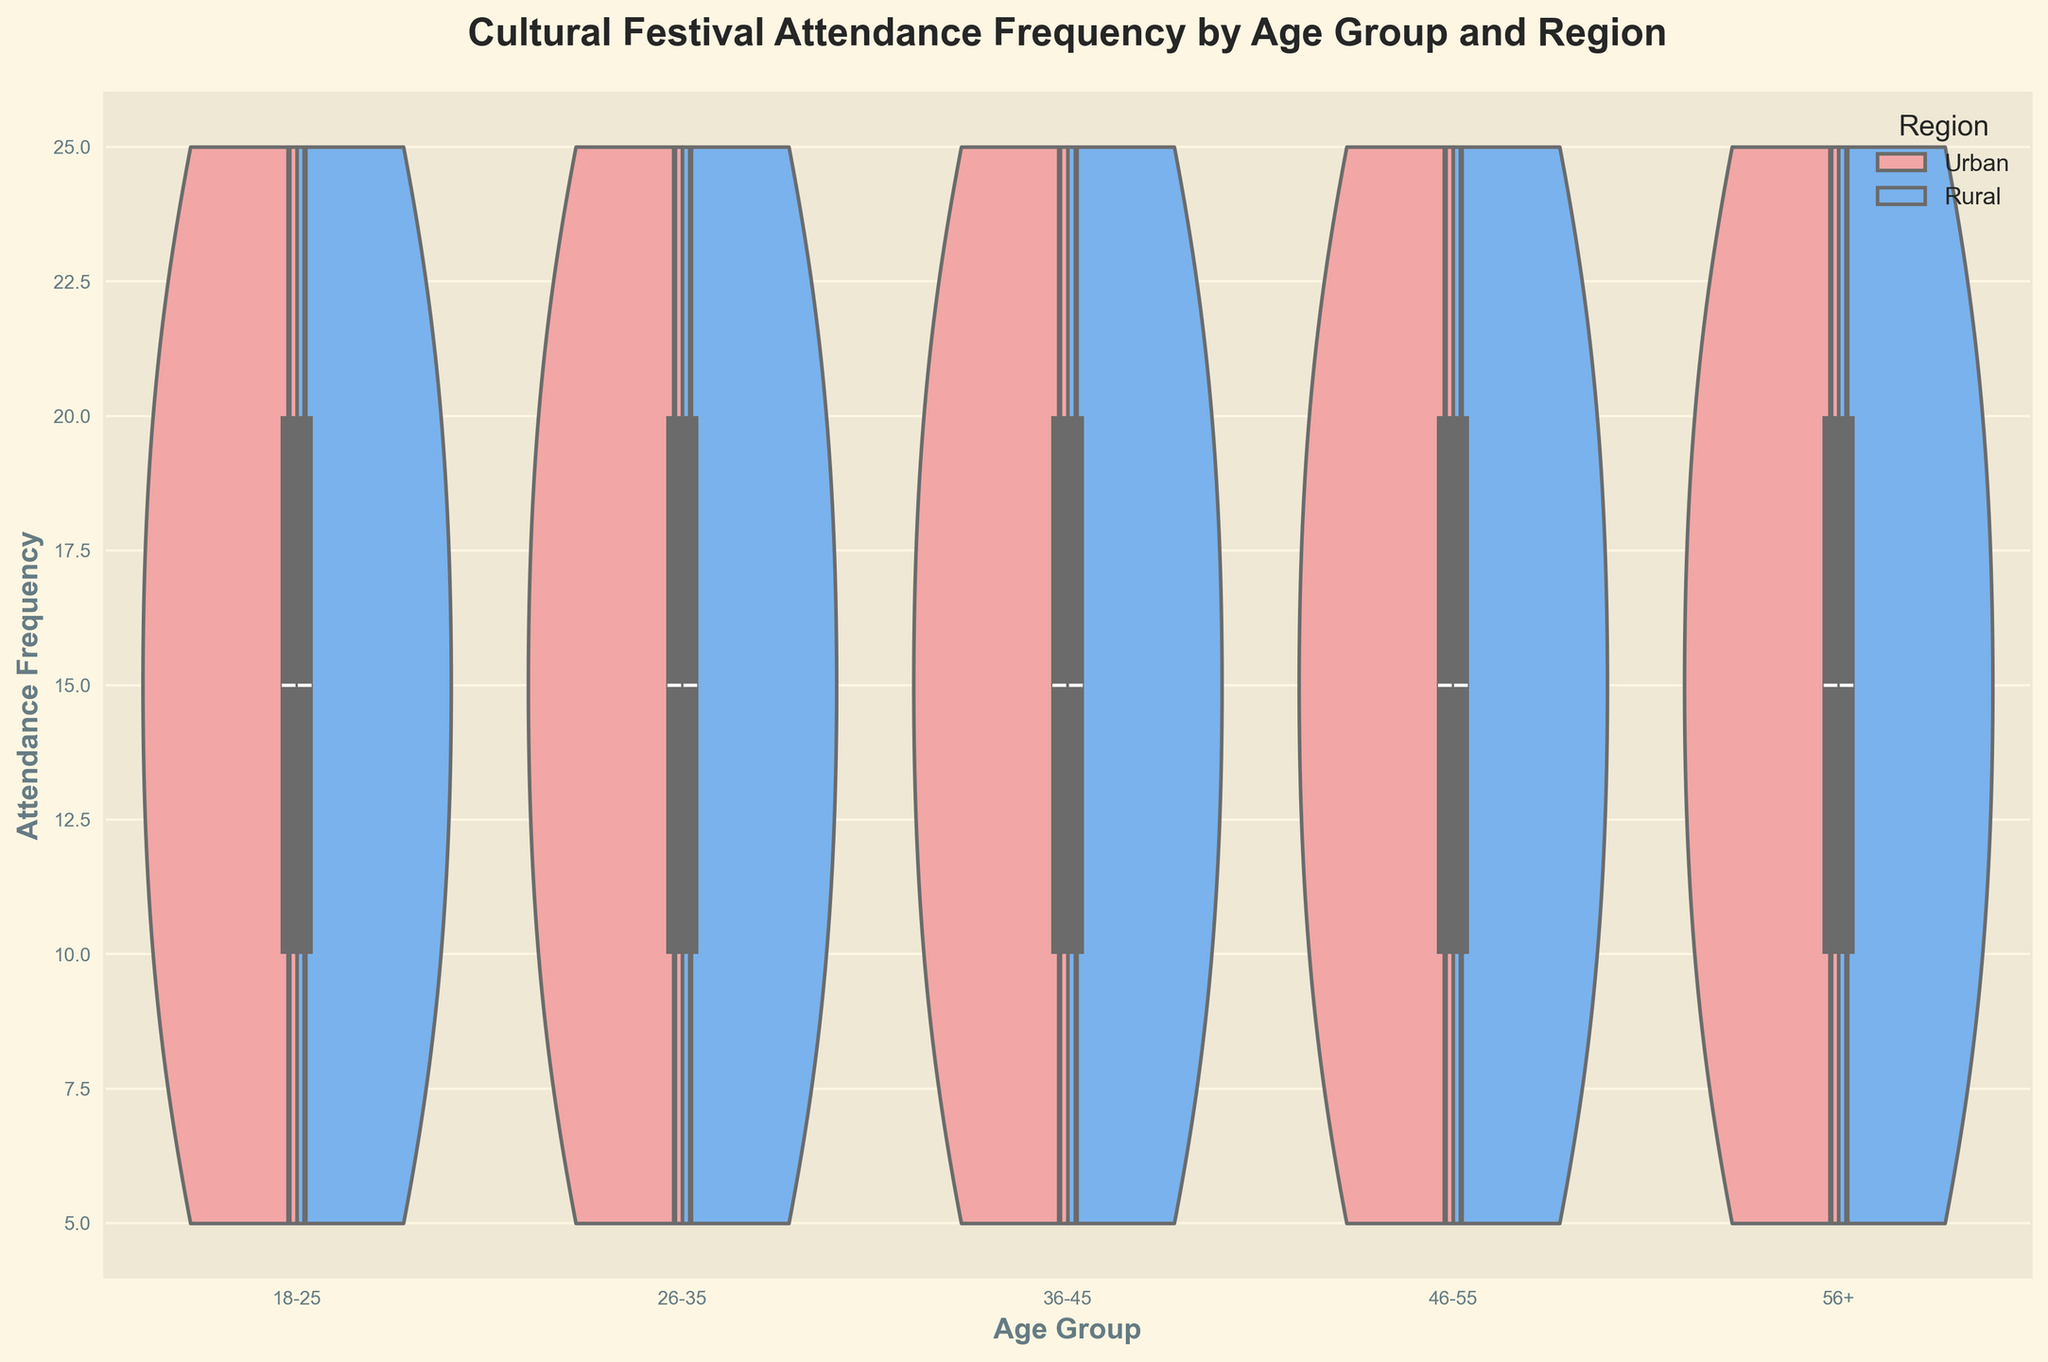what does the title of the plot indicate? The title of the plot, "Cultural Festival Attendance Frequency by Age Group and Region," indicates that the plot represents how often people attend cultural festivals, categorized by different age groups and whether they live in urban or rural regions.
Answer: It indicates the plot shows attendance frequency by age group and region what is represented on the x-axis? The x-axis represents different age groups of people. The plotted data is categorized into these age groups to compare attendance frequencies across them.
Answer: Age groups how are urban and rural regions visually differentiated in the plot? Urban and rural regions are differentiated using different colors. Urban regions are represented in a light reddish color, while rural regions are in a light bluish color.
Answer: By colors: light reddish for urban and light bluish for rural what is the attendance frequency for the 26-35 age group in urban areas? From the violin plot, the attendance frequency range for the 26-35 age group in urban areas spans from approximately 5 to 25, with a central tendency around 15 based on the box plot overlay.
Answer: Ranges from ~5 to ~25, with a central tendency around 15 which age group shows the widest spread in attendance frequency for rural regions? The age group 26-35 shows the widest spread in attendance frequency for the rural regions, as the violin plot is the most extended horizontally for this age group.
Answer: 26-35 in which region and age group is the median attendance frequency highest? The median attendance frequency is highest in urban regions for the 18-25 age group, indicated by the position of the median line in the box plot overlay.
Answer: Urban 18-25 how do attendance frequencies compare between urban and rural areas for the 46-55 age group? For the 46-55 age group, urban areas show a larger spread and higher median in attendance frequencies compared to rural areas, which are more condensed with lower frequencies.
Answer: Urban shows larger spread and higher median which age group and region combination has the least variation in attendance frequency? The 56+ age group in urban regions has the least variation in attendance frequency, indicated by the narrower width of the violin plot.
Answer: Urban 56+ how does the attendance frequency distribution of 36-45 age group in rural areas compare to urban areas? In the 36-45 age group, rural areas have a smaller spread and slightly lower median attendance frequency compared to urban areas, as depicted by narrower and more centered distributions.
Answer: Rural areas show smaller spread and lower median 